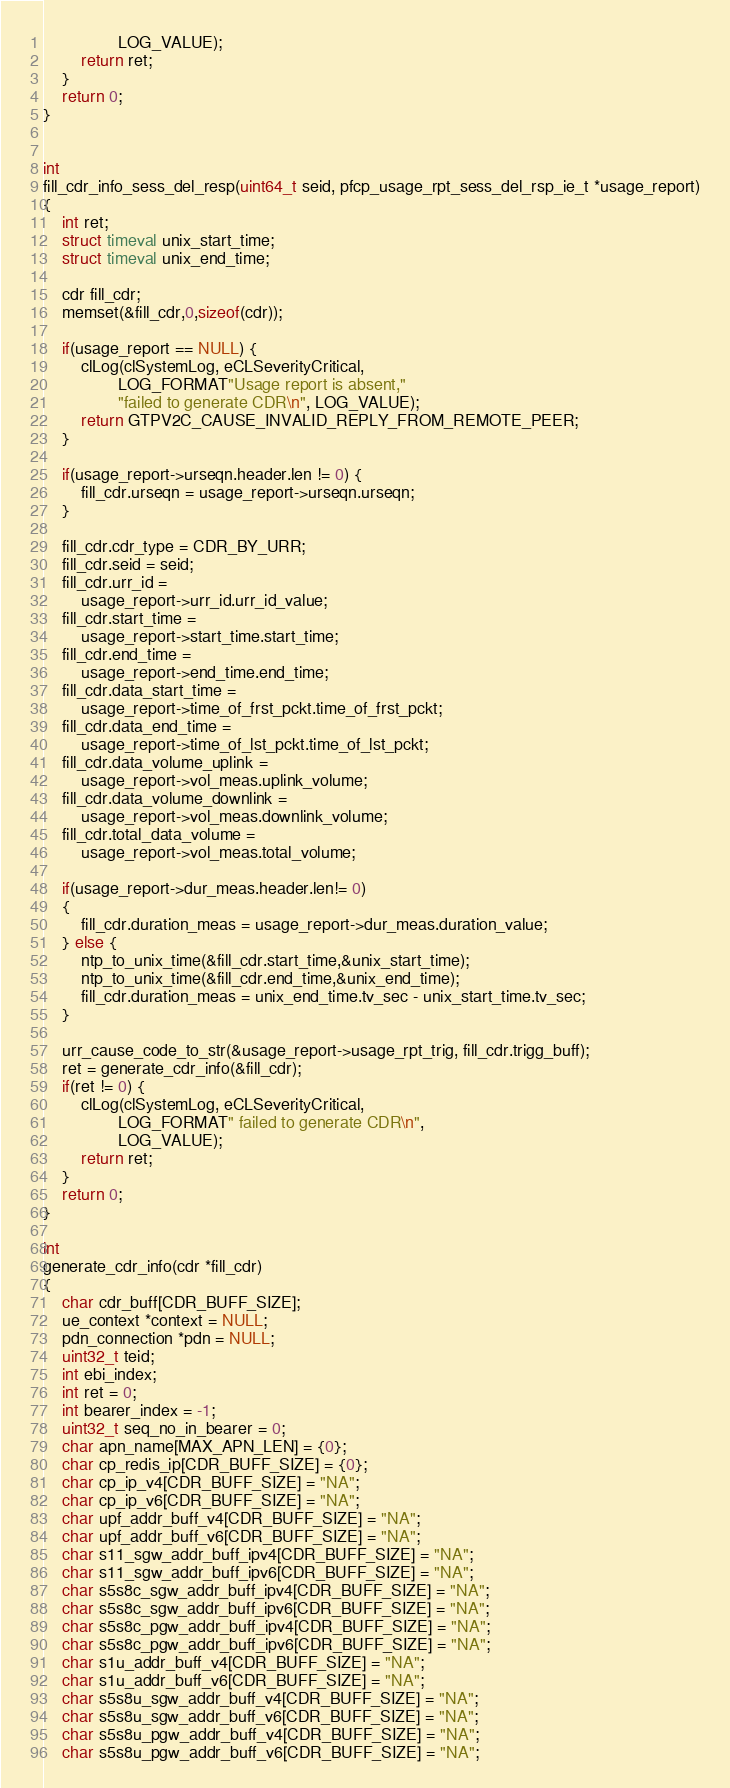Convert code to text. <code><loc_0><loc_0><loc_500><loc_500><_C_>				LOG_VALUE);
		return ret;
	}
	return 0;
}


int
fill_cdr_info_sess_del_resp(uint64_t seid, pfcp_usage_rpt_sess_del_rsp_ie_t *usage_report)
{
	int ret;
	struct timeval unix_start_time;
	struct timeval unix_end_time;

	cdr fill_cdr;
	memset(&fill_cdr,0,sizeof(cdr));

	if(usage_report == NULL) {
		clLog(clSystemLog, eCLSeverityCritical,
				LOG_FORMAT"Usage report is absent,"
				"failed to generate CDR\n", LOG_VALUE);
		return GTPV2C_CAUSE_INVALID_REPLY_FROM_REMOTE_PEER;
	}

	if(usage_report->urseqn.header.len != 0) {
		fill_cdr.urseqn = usage_report->urseqn.urseqn;
	}

	fill_cdr.cdr_type = CDR_BY_URR;
	fill_cdr.seid = seid;
	fill_cdr.urr_id =
		usage_report->urr_id.urr_id_value;
	fill_cdr.start_time =
		usage_report->start_time.start_time;
	fill_cdr.end_time =
		usage_report->end_time.end_time;
	fill_cdr.data_start_time =
		usage_report->time_of_frst_pckt.time_of_frst_pckt;
	fill_cdr.data_end_time =
		usage_report->time_of_lst_pckt.time_of_lst_pckt;
	fill_cdr.data_volume_uplink =
		usage_report->vol_meas.uplink_volume;
	fill_cdr.data_volume_downlink =
		usage_report->vol_meas.downlink_volume;
	fill_cdr.total_data_volume =
		usage_report->vol_meas.total_volume;

	if(usage_report->dur_meas.header.len!= 0)
	{
		fill_cdr.duration_meas = usage_report->dur_meas.duration_value;
	} else {
		ntp_to_unix_time(&fill_cdr.start_time,&unix_start_time);
		ntp_to_unix_time(&fill_cdr.end_time,&unix_end_time);
		fill_cdr.duration_meas = unix_end_time.tv_sec - unix_start_time.tv_sec;
	}

	urr_cause_code_to_str(&usage_report->usage_rpt_trig, fill_cdr.trigg_buff);
	ret = generate_cdr_info(&fill_cdr);
	if(ret != 0) {
		clLog(clSystemLog, eCLSeverityCritical,
				LOG_FORMAT" failed to generate CDR\n",
				LOG_VALUE);
		return ret;
	}
	return 0;
}

int
generate_cdr_info(cdr *fill_cdr)
{
	char cdr_buff[CDR_BUFF_SIZE];
	ue_context *context = NULL;
	pdn_connection *pdn = NULL;
	uint32_t teid;
	int ebi_index;
	int ret = 0;
	int bearer_index = -1;
	uint32_t seq_no_in_bearer = 0;
	char apn_name[MAX_APN_LEN] = {0};
	char cp_redis_ip[CDR_BUFF_SIZE] = {0};
	char cp_ip_v4[CDR_BUFF_SIZE] = "NA";
	char cp_ip_v6[CDR_BUFF_SIZE] = "NA";
	char upf_addr_buff_v4[CDR_BUFF_SIZE] = "NA";
	char upf_addr_buff_v6[CDR_BUFF_SIZE] = "NA";
	char s11_sgw_addr_buff_ipv4[CDR_BUFF_SIZE] = "NA";
	char s11_sgw_addr_buff_ipv6[CDR_BUFF_SIZE] = "NA";
	char s5s8c_sgw_addr_buff_ipv4[CDR_BUFF_SIZE] = "NA";
	char s5s8c_sgw_addr_buff_ipv6[CDR_BUFF_SIZE] = "NA";
	char s5s8c_pgw_addr_buff_ipv4[CDR_BUFF_SIZE] = "NA";
	char s5s8c_pgw_addr_buff_ipv6[CDR_BUFF_SIZE] = "NA";
	char s1u_addr_buff_v4[CDR_BUFF_SIZE] = "NA";
	char s1u_addr_buff_v6[CDR_BUFF_SIZE] = "NA";
	char s5s8u_sgw_addr_buff_v4[CDR_BUFF_SIZE] = "NA";
	char s5s8u_sgw_addr_buff_v6[CDR_BUFF_SIZE] = "NA";
	char s5s8u_pgw_addr_buff_v4[CDR_BUFF_SIZE] = "NA";
	char s5s8u_pgw_addr_buff_v6[CDR_BUFF_SIZE] = "NA";</code> 